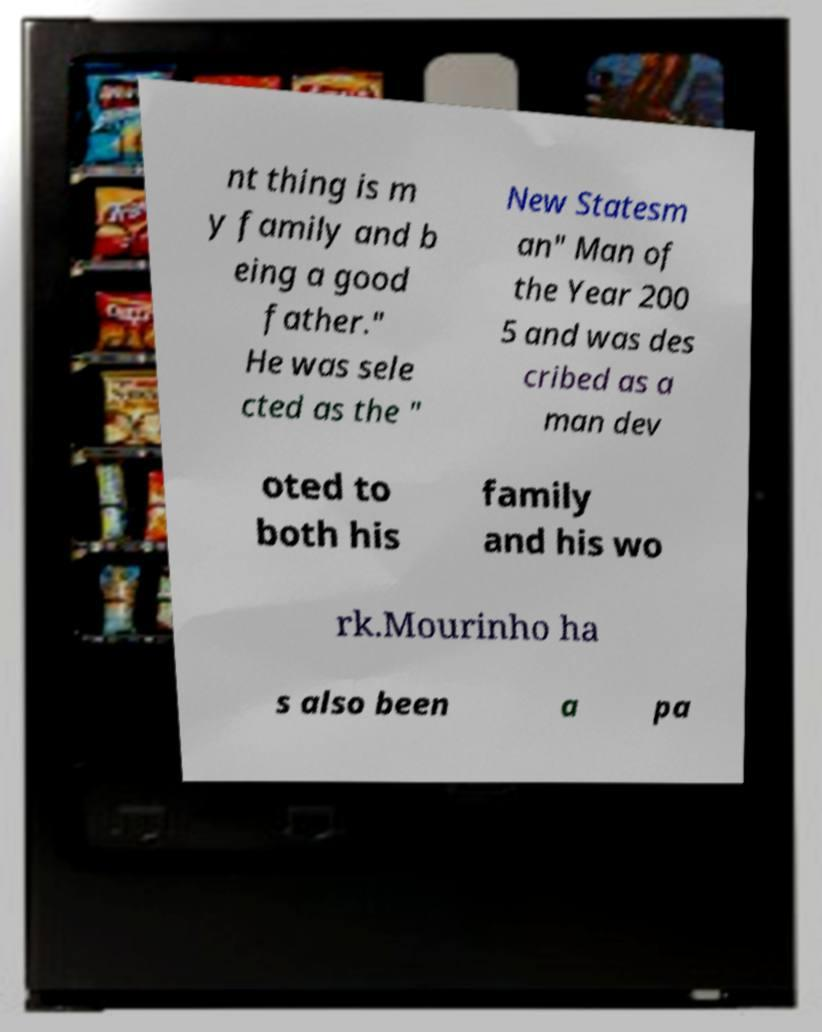Can you accurately transcribe the text from the provided image for me? The text in the image appears to read: "nt thing is m y family and b eing a good father." He was sele cted as the " New Statesm an" Man of the Year 200 5 and was des cribed as a man dev oted to both his family and his wo rk.Mourinho ha s also been a pa..." Due to the muddled and partial visibility of the text, the full and exact transcription might be slightly inaccurate. 